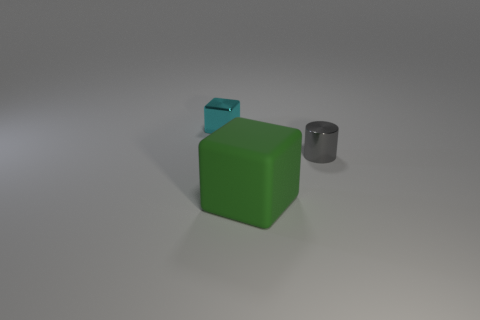Add 2 cyan metallic objects. How many objects exist? 5 Subtract all blocks. How many objects are left? 1 Add 2 cyan things. How many cyan things are left? 3 Add 2 matte things. How many matte things exist? 3 Subtract 0 cyan cylinders. How many objects are left? 3 Subtract all blue balls. Subtract all cubes. How many objects are left? 1 